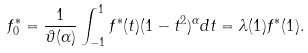Convert formula to latex. <formula><loc_0><loc_0><loc_500><loc_500>f ^ { * } _ { 0 } = \frac { 1 } { \vartheta ( \alpha ) } \int _ { - 1 } ^ { 1 } f ^ { * } ( t ) ( 1 - t ^ { 2 } ) ^ { \alpha } d t = \lambda ( 1 ) f ^ { * } ( 1 ) .</formula> 